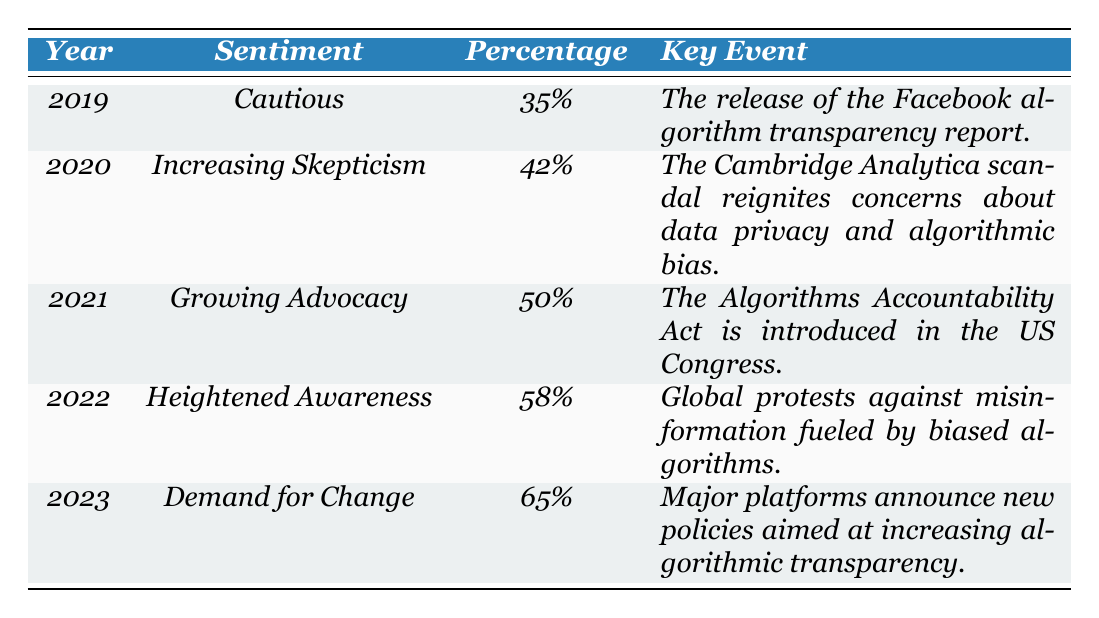What was the public sentiment in 2020? According to the table, the sentiment for the year 2020 is labeled as "Increasing Skepticism."
Answer: Increasing Skepticism Which year had the highest percentage of public sentiment? The table shows that in 2023, the percentage of public sentiment reached 65%, which is the highest compared to the other years.
Answer: 2023 What was the percentage of those who felt "Cautious" in 2019? The table indicates that 35% of the public sentiment in 2019 was categorized as "Cautious."
Answer: 35% What is the difference in public sentiment percentage from 2021 to 2022? To find the difference, subtract the percentage in 2021 (50%) from the percentage in 2022 (58%): 58% - 50% = 8%.
Answer: 8% Was there an increase or decrease in public sentiment from 2020 to 2021? From the table, 2020 shows a sentiment percentage of 42% and 2021 has a percentage of 50%, indicating an increase.
Answer: Increase What were the sentiments over the years leading up to 2023? The sentiments were "Cautious" in 2019, "Increasing Skepticism" in 2020, "Growing Advocacy" in 2021, "Heightened Awareness" in 2022, and "Demand for Change" in 2023.
Answer: Cautious, Increasing Skepticism, Growing Advocacy, Heightened Awareness, Demand for Change How much did the sentiment percentage rise from 2019 to 2023? The percentage increased from 35% in 2019 to 65% in 2023. The difference is 65% - 35% = 30%.
Answer: 30% Which key event in 2021 was related to the sentiment "Growing Advocacy"? The key event related to the sentiment "Growing Advocacy" is the introduction of the Algorithms Accountability Act in the US Congress.
Answer: Algorithms Accountability Act introduced in Congress Was "Demand for Change" the only sentiment that had a percentage above 60%? Yes, according to the table, only the sentiment "Demand for Change" in 2023 has a percentage above 60%.
Answer: Yes How did global events influence public sentiment in 2022? The table states that global protests against misinformation fueled by biased algorithms in 2022 led to "Heightened Awareness" with a percentage of 58%.
Answer: Heightened Awareness due to global protests What was the trend from 2019 to 2023 in terms of public sentiment regarding algorithmic transparency? The trend shows a consistent increase in public sentiment from "Cautious" at 35% in 2019 to "Demand for Change" at 65% in 2023, suggesting growing concern and activism over the years.
Answer: Increasing trend in public sentiment 